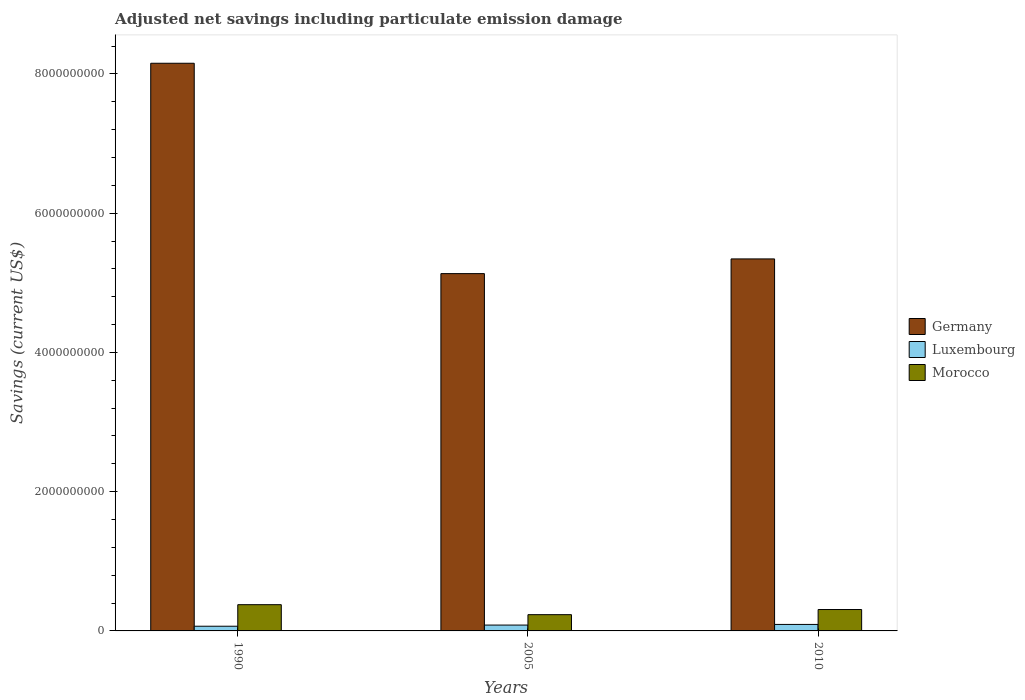How many different coloured bars are there?
Ensure brevity in your answer.  3. Are the number of bars per tick equal to the number of legend labels?
Offer a terse response. Yes. Are the number of bars on each tick of the X-axis equal?
Keep it short and to the point. Yes. How many bars are there on the 3rd tick from the right?
Your answer should be compact. 3. What is the label of the 3rd group of bars from the left?
Provide a short and direct response. 2010. What is the net savings in Luxembourg in 2005?
Provide a short and direct response. 8.40e+07. Across all years, what is the maximum net savings in Morocco?
Provide a short and direct response. 3.77e+08. Across all years, what is the minimum net savings in Morocco?
Keep it short and to the point. 2.33e+08. What is the total net savings in Luxembourg in the graph?
Provide a short and direct response. 2.45e+08. What is the difference between the net savings in Germany in 1990 and that in 2010?
Your response must be concise. 2.81e+09. What is the difference between the net savings in Luxembourg in 2010 and the net savings in Germany in 1990?
Provide a succinct answer. -8.06e+09. What is the average net savings in Morocco per year?
Make the answer very short. 3.06e+08. In the year 2005, what is the difference between the net savings in Morocco and net savings in Luxembourg?
Your answer should be compact. 1.49e+08. What is the ratio of the net savings in Germany in 1990 to that in 2005?
Offer a very short reply. 1.59. Is the net savings in Luxembourg in 1990 less than that in 2005?
Give a very brief answer. Yes. Is the difference between the net savings in Morocco in 1990 and 2005 greater than the difference between the net savings in Luxembourg in 1990 and 2005?
Give a very brief answer. Yes. What is the difference between the highest and the second highest net savings in Germany?
Offer a terse response. 2.81e+09. What is the difference between the highest and the lowest net savings in Luxembourg?
Ensure brevity in your answer.  2.60e+07. In how many years, is the net savings in Luxembourg greater than the average net savings in Luxembourg taken over all years?
Provide a short and direct response. 2. What does the 3rd bar from the left in 1990 represents?
Provide a succinct answer. Morocco. What does the 3rd bar from the right in 1990 represents?
Offer a terse response. Germany. Is it the case that in every year, the sum of the net savings in Luxembourg and net savings in Morocco is greater than the net savings in Germany?
Your answer should be compact. No. How many bars are there?
Keep it short and to the point. 9. What is the difference between two consecutive major ticks on the Y-axis?
Your answer should be very brief. 2.00e+09. Are the values on the major ticks of Y-axis written in scientific E-notation?
Your answer should be compact. No. Does the graph contain grids?
Ensure brevity in your answer.  No. Where does the legend appear in the graph?
Offer a very short reply. Center right. How many legend labels are there?
Your response must be concise. 3. How are the legend labels stacked?
Your response must be concise. Vertical. What is the title of the graph?
Ensure brevity in your answer.  Adjusted net savings including particulate emission damage. Does "Eritrea" appear as one of the legend labels in the graph?
Offer a very short reply. No. What is the label or title of the X-axis?
Give a very brief answer. Years. What is the label or title of the Y-axis?
Offer a very short reply. Savings (current US$). What is the Savings (current US$) in Germany in 1990?
Keep it short and to the point. 8.15e+09. What is the Savings (current US$) in Luxembourg in 1990?
Give a very brief answer. 6.74e+07. What is the Savings (current US$) in Morocco in 1990?
Provide a short and direct response. 3.77e+08. What is the Savings (current US$) of Germany in 2005?
Give a very brief answer. 5.13e+09. What is the Savings (current US$) in Luxembourg in 2005?
Offer a very short reply. 8.40e+07. What is the Savings (current US$) in Morocco in 2005?
Ensure brevity in your answer.  2.33e+08. What is the Savings (current US$) of Germany in 2010?
Ensure brevity in your answer.  5.34e+09. What is the Savings (current US$) in Luxembourg in 2010?
Offer a very short reply. 9.33e+07. What is the Savings (current US$) in Morocco in 2010?
Offer a very short reply. 3.07e+08. Across all years, what is the maximum Savings (current US$) in Germany?
Your answer should be very brief. 8.15e+09. Across all years, what is the maximum Savings (current US$) in Luxembourg?
Your response must be concise. 9.33e+07. Across all years, what is the maximum Savings (current US$) of Morocco?
Provide a succinct answer. 3.77e+08. Across all years, what is the minimum Savings (current US$) in Germany?
Make the answer very short. 5.13e+09. Across all years, what is the minimum Savings (current US$) of Luxembourg?
Offer a very short reply. 6.74e+07. Across all years, what is the minimum Savings (current US$) of Morocco?
Make the answer very short. 2.33e+08. What is the total Savings (current US$) in Germany in the graph?
Provide a succinct answer. 1.86e+1. What is the total Savings (current US$) of Luxembourg in the graph?
Provide a short and direct response. 2.45e+08. What is the total Savings (current US$) of Morocco in the graph?
Provide a succinct answer. 9.18e+08. What is the difference between the Savings (current US$) of Germany in 1990 and that in 2005?
Ensure brevity in your answer.  3.02e+09. What is the difference between the Savings (current US$) of Luxembourg in 1990 and that in 2005?
Provide a succinct answer. -1.67e+07. What is the difference between the Savings (current US$) in Morocco in 1990 and that in 2005?
Provide a short and direct response. 1.44e+08. What is the difference between the Savings (current US$) of Germany in 1990 and that in 2010?
Provide a succinct answer. 2.81e+09. What is the difference between the Savings (current US$) of Luxembourg in 1990 and that in 2010?
Your answer should be very brief. -2.60e+07. What is the difference between the Savings (current US$) of Morocco in 1990 and that in 2010?
Your answer should be very brief. 6.97e+07. What is the difference between the Savings (current US$) of Germany in 2005 and that in 2010?
Make the answer very short. -2.11e+08. What is the difference between the Savings (current US$) in Luxembourg in 2005 and that in 2010?
Your answer should be very brief. -9.32e+06. What is the difference between the Savings (current US$) in Morocco in 2005 and that in 2010?
Offer a very short reply. -7.38e+07. What is the difference between the Savings (current US$) of Germany in 1990 and the Savings (current US$) of Luxembourg in 2005?
Your response must be concise. 8.07e+09. What is the difference between the Savings (current US$) in Germany in 1990 and the Savings (current US$) in Morocco in 2005?
Offer a terse response. 7.92e+09. What is the difference between the Savings (current US$) of Luxembourg in 1990 and the Savings (current US$) of Morocco in 2005?
Offer a very short reply. -1.66e+08. What is the difference between the Savings (current US$) of Germany in 1990 and the Savings (current US$) of Luxembourg in 2010?
Provide a succinct answer. 8.06e+09. What is the difference between the Savings (current US$) of Germany in 1990 and the Savings (current US$) of Morocco in 2010?
Offer a very short reply. 7.85e+09. What is the difference between the Savings (current US$) in Luxembourg in 1990 and the Savings (current US$) in Morocco in 2010?
Offer a very short reply. -2.40e+08. What is the difference between the Savings (current US$) of Germany in 2005 and the Savings (current US$) of Luxembourg in 2010?
Your answer should be compact. 5.04e+09. What is the difference between the Savings (current US$) of Germany in 2005 and the Savings (current US$) of Morocco in 2010?
Your answer should be very brief. 4.83e+09. What is the difference between the Savings (current US$) in Luxembourg in 2005 and the Savings (current US$) in Morocco in 2010?
Your answer should be very brief. -2.23e+08. What is the average Savings (current US$) of Germany per year?
Offer a very short reply. 6.21e+09. What is the average Savings (current US$) in Luxembourg per year?
Give a very brief answer. 8.16e+07. What is the average Savings (current US$) in Morocco per year?
Your answer should be compact. 3.06e+08. In the year 1990, what is the difference between the Savings (current US$) in Germany and Savings (current US$) in Luxembourg?
Your response must be concise. 8.09e+09. In the year 1990, what is the difference between the Savings (current US$) in Germany and Savings (current US$) in Morocco?
Ensure brevity in your answer.  7.78e+09. In the year 1990, what is the difference between the Savings (current US$) of Luxembourg and Savings (current US$) of Morocco?
Your answer should be very brief. -3.10e+08. In the year 2005, what is the difference between the Savings (current US$) of Germany and Savings (current US$) of Luxembourg?
Provide a succinct answer. 5.05e+09. In the year 2005, what is the difference between the Savings (current US$) in Germany and Savings (current US$) in Morocco?
Offer a very short reply. 4.90e+09. In the year 2005, what is the difference between the Savings (current US$) in Luxembourg and Savings (current US$) in Morocco?
Provide a succinct answer. -1.49e+08. In the year 2010, what is the difference between the Savings (current US$) in Germany and Savings (current US$) in Luxembourg?
Your response must be concise. 5.25e+09. In the year 2010, what is the difference between the Savings (current US$) of Germany and Savings (current US$) of Morocco?
Keep it short and to the point. 5.04e+09. In the year 2010, what is the difference between the Savings (current US$) in Luxembourg and Savings (current US$) in Morocco?
Offer a very short reply. -2.14e+08. What is the ratio of the Savings (current US$) in Germany in 1990 to that in 2005?
Offer a very short reply. 1.59. What is the ratio of the Savings (current US$) in Luxembourg in 1990 to that in 2005?
Offer a very short reply. 0.8. What is the ratio of the Savings (current US$) of Morocco in 1990 to that in 2005?
Your response must be concise. 1.61. What is the ratio of the Savings (current US$) of Germany in 1990 to that in 2010?
Provide a short and direct response. 1.53. What is the ratio of the Savings (current US$) in Luxembourg in 1990 to that in 2010?
Your answer should be very brief. 0.72. What is the ratio of the Savings (current US$) of Morocco in 1990 to that in 2010?
Offer a very short reply. 1.23. What is the ratio of the Savings (current US$) in Germany in 2005 to that in 2010?
Your answer should be very brief. 0.96. What is the ratio of the Savings (current US$) in Luxembourg in 2005 to that in 2010?
Ensure brevity in your answer.  0.9. What is the ratio of the Savings (current US$) in Morocco in 2005 to that in 2010?
Ensure brevity in your answer.  0.76. What is the difference between the highest and the second highest Savings (current US$) of Germany?
Give a very brief answer. 2.81e+09. What is the difference between the highest and the second highest Savings (current US$) of Luxembourg?
Keep it short and to the point. 9.32e+06. What is the difference between the highest and the second highest Savings (current US$) of Morocco?
Provide a succinct answer. 6.97e+07. What is the difference between the highest and the lowest Savings (current US$) of Germany?
Make the answer very short. 3.02e+09. What is the difference between the highest and the lowest Savings (current US$) of Luxembourg?
Ensure brevity in your answer.  2.60e+07. What is the difference between the highest and the lowest Savings (current US$) of Morocco?
Provide a short and direct response. 1.44e+08. 